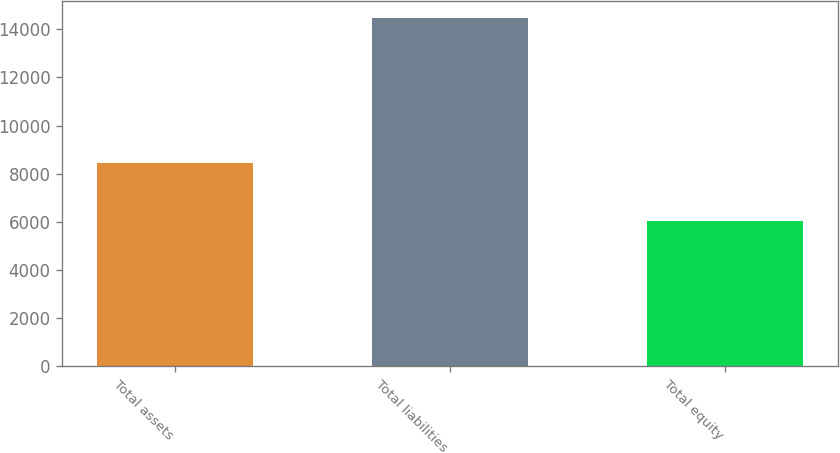Convert chart. <chart><loc_0><loc_0><loc_500><loc_500><bar_chart><fcel>Total assets<fcel>Total liabilities<fcel>Total equity<nl><fcel>8429<fcel>14448<fcel>6019<nl></chart> 